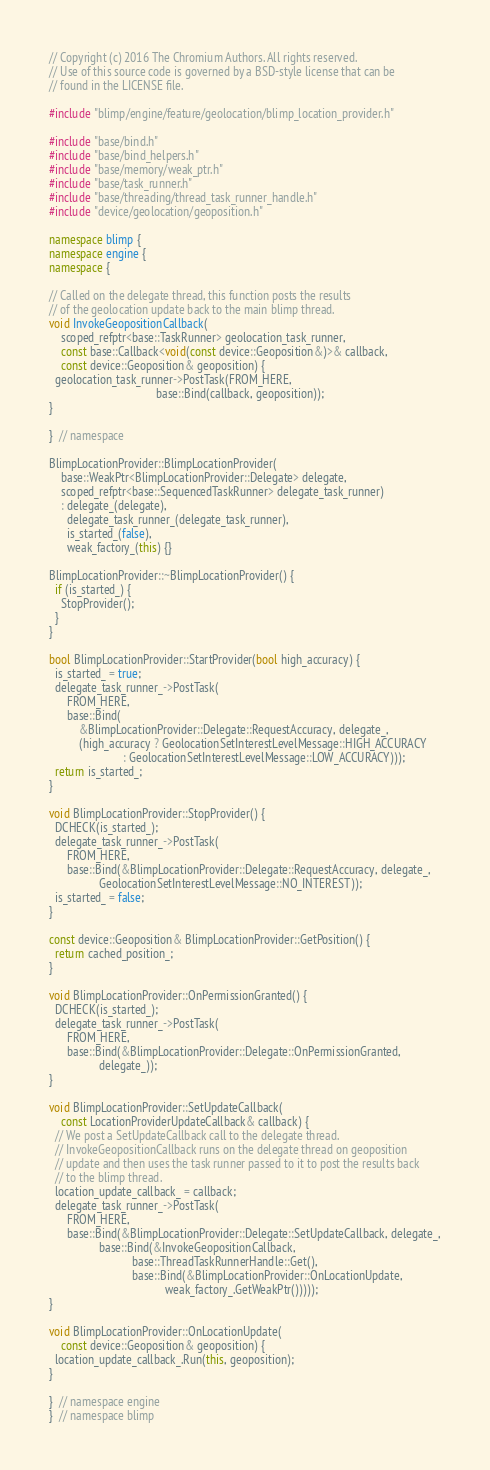Convert code to text. <code><loc_0><loc_0><loc_500><loc_500><_C++_>// Copyright (c) 2016 The Chromium Authors. All rights reserved.
// Use of this source code is governed by a BSD-style license that can be
// found in the LICENSE file.

#include "blimp/engine/feature/geolocation/blimp_location_provider.h"

#include "base/bind.h"
#include "base/bind_helpers.h"
#include "base/memory/weak_ptr.h"
#include "base/task_runner.h"
#include "base/threading/thread_task_runner_handle.h"
#include "device/geolocation/geoposition.h"

namespace blimp {
namespace engine {
namespace {

// Called on the delegate thread, this function posts the results
// of the geolocation update back to the main blimp thread.
void InvokeGeopositionCallback(
    scoped_refptr<base::TaskRunner> geolocation_task_runner,
    const base::Callback<void(const device::Geoposition&)>& callback,
    const device::Geoposition& geoposition) {
  geolocation_task_runner->PostTask(FROM_HERE,
                                    base::Bind(callback, geoposition));
}

}  // namespace

BlimpLocationProvider::BlimpLocationProvider(
    base::WeakPtr<BlimpLocationProvider::Delegate> delegate,
    scoped_refptr<base::SequencedTaskRunner> delegate_task_runner)
    : delegate_(delegate),
      delegate_task_runner_(delegate_task_runner),
      is_started_(false),
      weak_factory_(this) {}

BlimpLocationProvider::~BlimpLocationProvider() {
  if (is_started_) {
    StopProvider();
  }
}

bool BlimpLocationProvider::StartProvider(bool high_accuracy) {
  is_started_ = true;
  delegate_task_runner_->PostTask(
      FROM_HERE,
      base::Bind(
          &BlimpLocationProvider::Delegate::RequestAccuracy, delegate_,
          (high_accuracy ? GeolocationSetInterestLevelMessage::HIGH_ACCURACY
                         : GeolocationSetInterestLevelMessage::LOW_ACCURACY)));
  return is_started_;
}

void BlimpLocationProvider::StopProvider() {
  DCHECK(is_started_);
  delegate_task_runner_->PostTask(
      FROM_HERE,
      base::Bind(&BlimpLocationProvider::Delegate::RequestAccuracy, delegate_,
                 GeolocationSetInterestLevelMessage::NO_INTEREST));
  is_started_ = false;
}

const device::Geoposition& BlimpLocationProvider::GetPosition() {
  return cached_position_;
}

void BlimpLocationProvider::OnPermissionGranted() {
  DCHECK(is_started_);
  delegate_task_runner_->PostTask(
      FROM_HERE,
      base::Bind(&BlimpLocationProvider::Delegate::OnPermissionGranted,
                 delegate_));
}

void BlimpLocationProvider::SetUpdateCallback(
    const LocationProviderUpdateCallback& callback) {
  // We post a SetUpdateCallback call to the delegate thread.
  // InvokeGeopositionCallback runs on the delegate thread on geoposition
  // update and then uses the task runner passed to it to post the results back
  // to the blimp thread.
  location_update_callback_ = callback;
  delegate_task_runner_->PostTask(
      FROM_HERE,
      base::Bind(&BlimpLocationProvider::Delegate::SetUpdateCallback, delegate_,
                 base::Bind(&InvokeGeopositionCallback,
                            base::ThreadTaskRunnerHandle::Get(),
                            base::Bind(&BlimpLocationProvider::OnLocationUpdate,
                                       weak_factory_.GetWeakPtr()))));
}

void BlimpLocationProvider::OnLocationUpdate(
    const device::Geoposition& geoposition) {
  location_update_callback_.Run(this, geoposition);
}

}  // namespace engine
}  // namespace blimp
</code> 